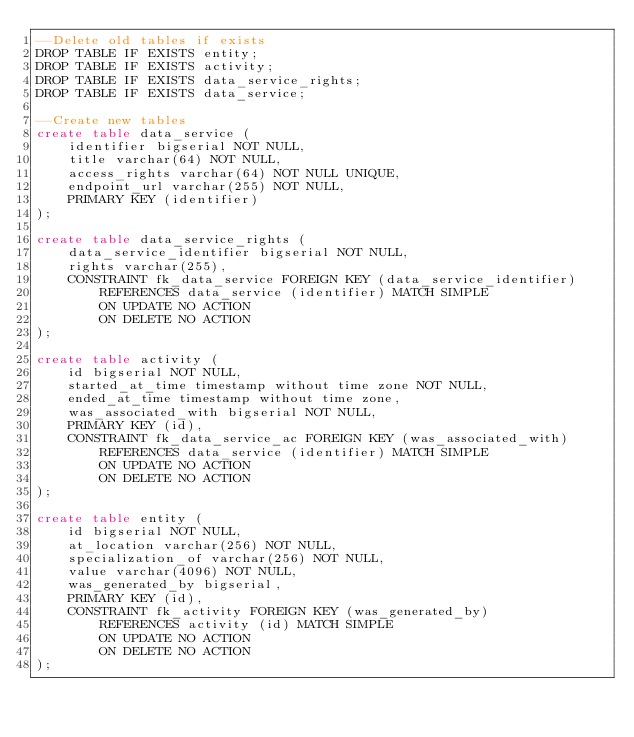Convert code to text. <code><loc_0><loc_0><loc_500><loc_500><_SQL_>--Delete old tables if exists
DROP TABLE IF EXISTS entity;
DROP TABLE IF EXISTS activity;
DROP TABLE IF EXISTS data_service_rights;
DROP TABLE IF EXISTS data_service;

--Create new tables
create table data_service (
    identifier bigserial NOT NULL,
    title varchar(64) NOT NULL,
    access_rights varchar(64) NOT NULL UNIQUE,
    endpoint_url varchar(255) NOT NULL,
    PRIMARY KEY (identifier)
);

create table data_service_rights (
    data_service_identifier bigserial NOT NULL,
    rights varchar(255),
    CONSTRAINT fk_data_service FOREIGN KEY (data_service_identifier)
        REFERENCES data_service (identifier) MATCH SIMPLE
        ON UPDATE NO ACTION
        ON DELETE NO ACTION
);

create table activity (
    id bigserial NOT NULL,
    started_at_time timestamp without time zone NOT NULL,
    ended_at_time timestamp without time zone,
    was_associated_with bigserial NOT NULL,
    PRIMARY KEY (id),
    CONSTRAINT fk_data_service_ac FOREIGN KEY (was_associated_with)
        REFERENCES data_service (identifier) MATCH SIMPLE
        ON UPDATE NO ACTION
        ON DELETE NO ACTION
);

create table entity (
    id bigserial NOT NULL,
    at_location varchar(256) NOT NULL,
    specialization_of varchar(256) NOT NULL,
    value varchar(4096) NOT NULL,
    was_generated_by bigserial,
    PRIMARY KEY (id),
    CONSTRAINT fk_activity FOREIGN KEY (was_generated_by)
        REFERENCES activity (id) MATCH SIMPLE
        ON UPDATE NO ACTION
        ON DELETE NO ACTION
);</code> 